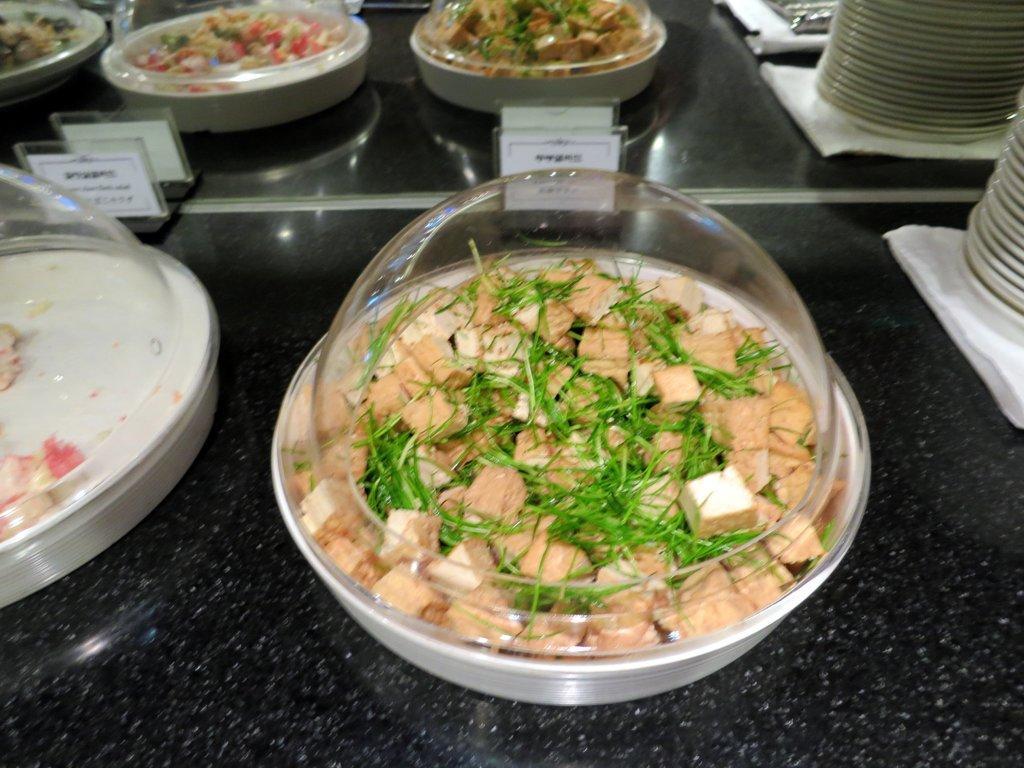Please provide a concise description of this image. In this image, I can see the bowls, which contains food items. These bowls are covered with the glass lids. These are the name boards. I can see the plates on the table. 